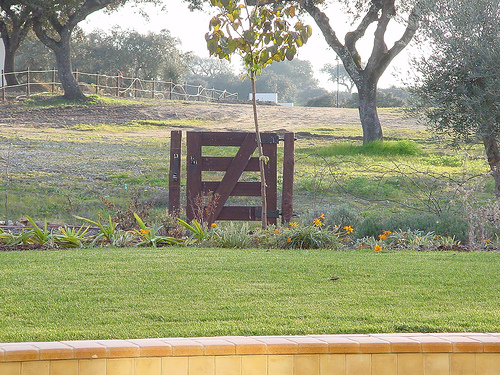<image>
Is there a gate to the right of the branches? Yes. From this viewpoint, the gate is positioned to the right side relative to the branches. 